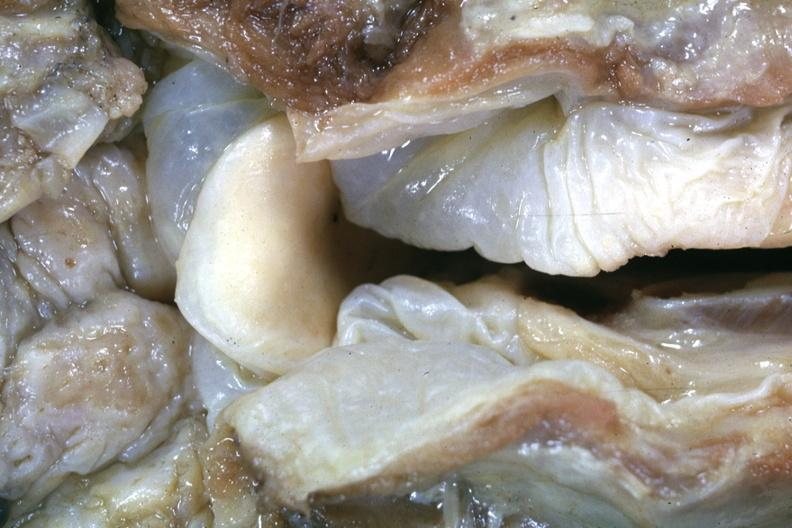when is close-up view of very edematous hypopharyngeal mucosa with opened larynx this is a very good example of a lesion seldom seen at autopsy slide a more distant view of this specimen?
Answer the question using a single word or phrase. After fixation 